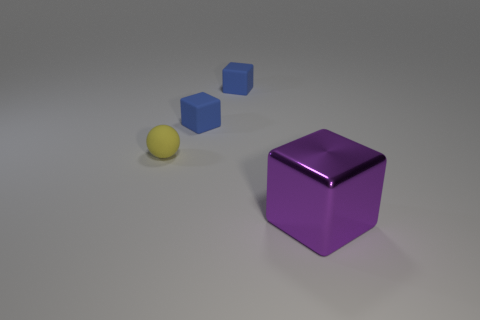Subtract all tiny rubber cubes. How many cubes are left? 1 Add 4 large blue metallic things. How many objects exist? 8 Subtract all blue cubes. How many cubes are left? 1 Subtract all blocks. How many objects are left? 1 Subtract all red cylinders. How many green balls are left? 0 Subtract all gray metal objects. Subtract all yellow objects. How many objects are left? 3 Add 2 tiny yellow spheres. How many tiny yellow spheres are left? 3 Add 4 matte spheres. How many matte spheres exist? 5 Subtract 1 yellow spheres. How many objects are left? 3 Subtract 1 balls. How many balls are left? 0 